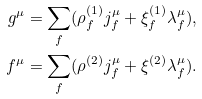Convert formula to latex. <formula><loc_0><loc_0><loc_500><loc_500>g ^ { \mu } & = \sum _ { f } ( \rho ^ { ( 1 ) } _ { f } j ^ { \mu } _ { f } + \xi ^ { ( 1 ) } _ { f } \lambda ^ { \mu } _ { f } ) , \\ f ^ { \mu } & = \sum _ { f } ( \rho ^ { ( 2 ) } j ^ { \mu } _ { f } + \xi ^ { ( 2 ) } \lambda ^ { \mu } _ { f } ) .</formula> 